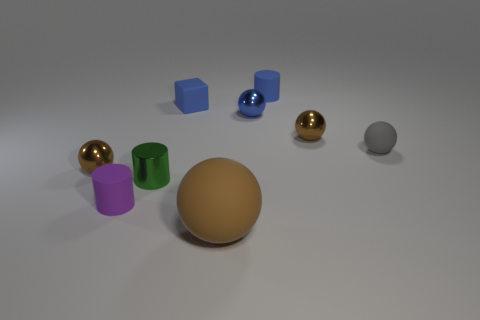What material is the small cylinder that is behind the small matte sphere to the right of the purple cylinder that is on the left side of the large sphere?
Provide a short and direct response. Rubber. Do the tiny rubber sphere and the tiny cube have the same color?
Keep it short and to the point. No. Is there a big rubber ball that has the same color as the small rubber cube?
Ensure brevity in your answer.  No. The blue metallic thing that is the same size as the green shiny cylinder is what shape?
Your answer should be very brief. Sphere. Is the number of big gray balls less than the number of metallic objects?
Your answer should be compact. Yes. What number of green shiny objects have the same size as the gray matte ball?
Keep it short and to the point. 1. What is the shape of the small metallic object that is the same color as the cube?
Give a very brief answer. Sphere. What is the material of the small purple cylinder?
Ensure brevity in your answer.  Rubber. There is a matte sphere on the right side of the big brown rubber sphere; what is its size?
Keep it short and to the point. Small. What number of small gray things have the same shape as the small green thing?
Your answer should be compact. 0. 